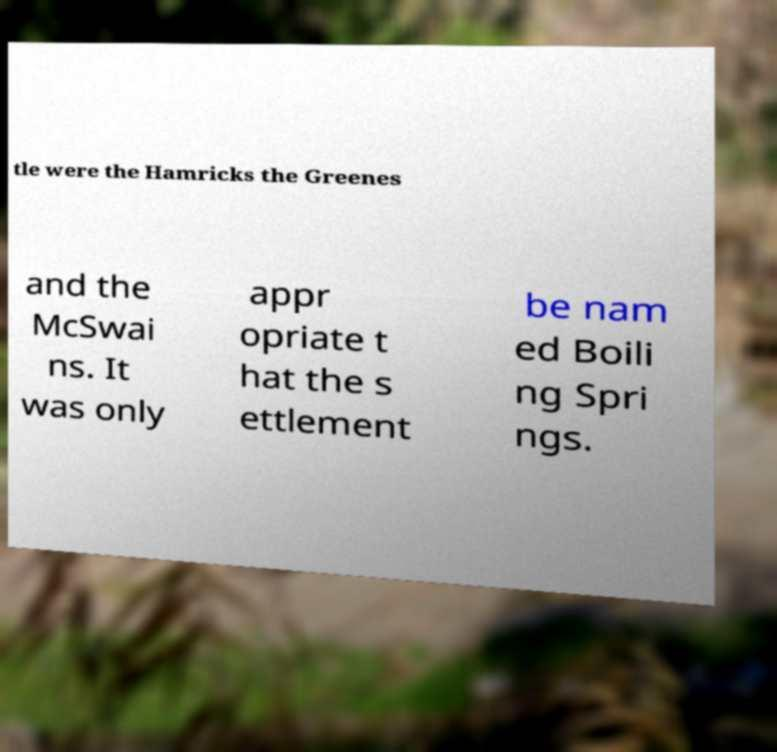There's text embedded in this image that I need extracted. Can you transcribe it verbatim? tle were the Hamricks the Greenes and the McSwai ns. It was only appr opriate t hat the s ettlement be nam ed Boili ng Spri ngs. 